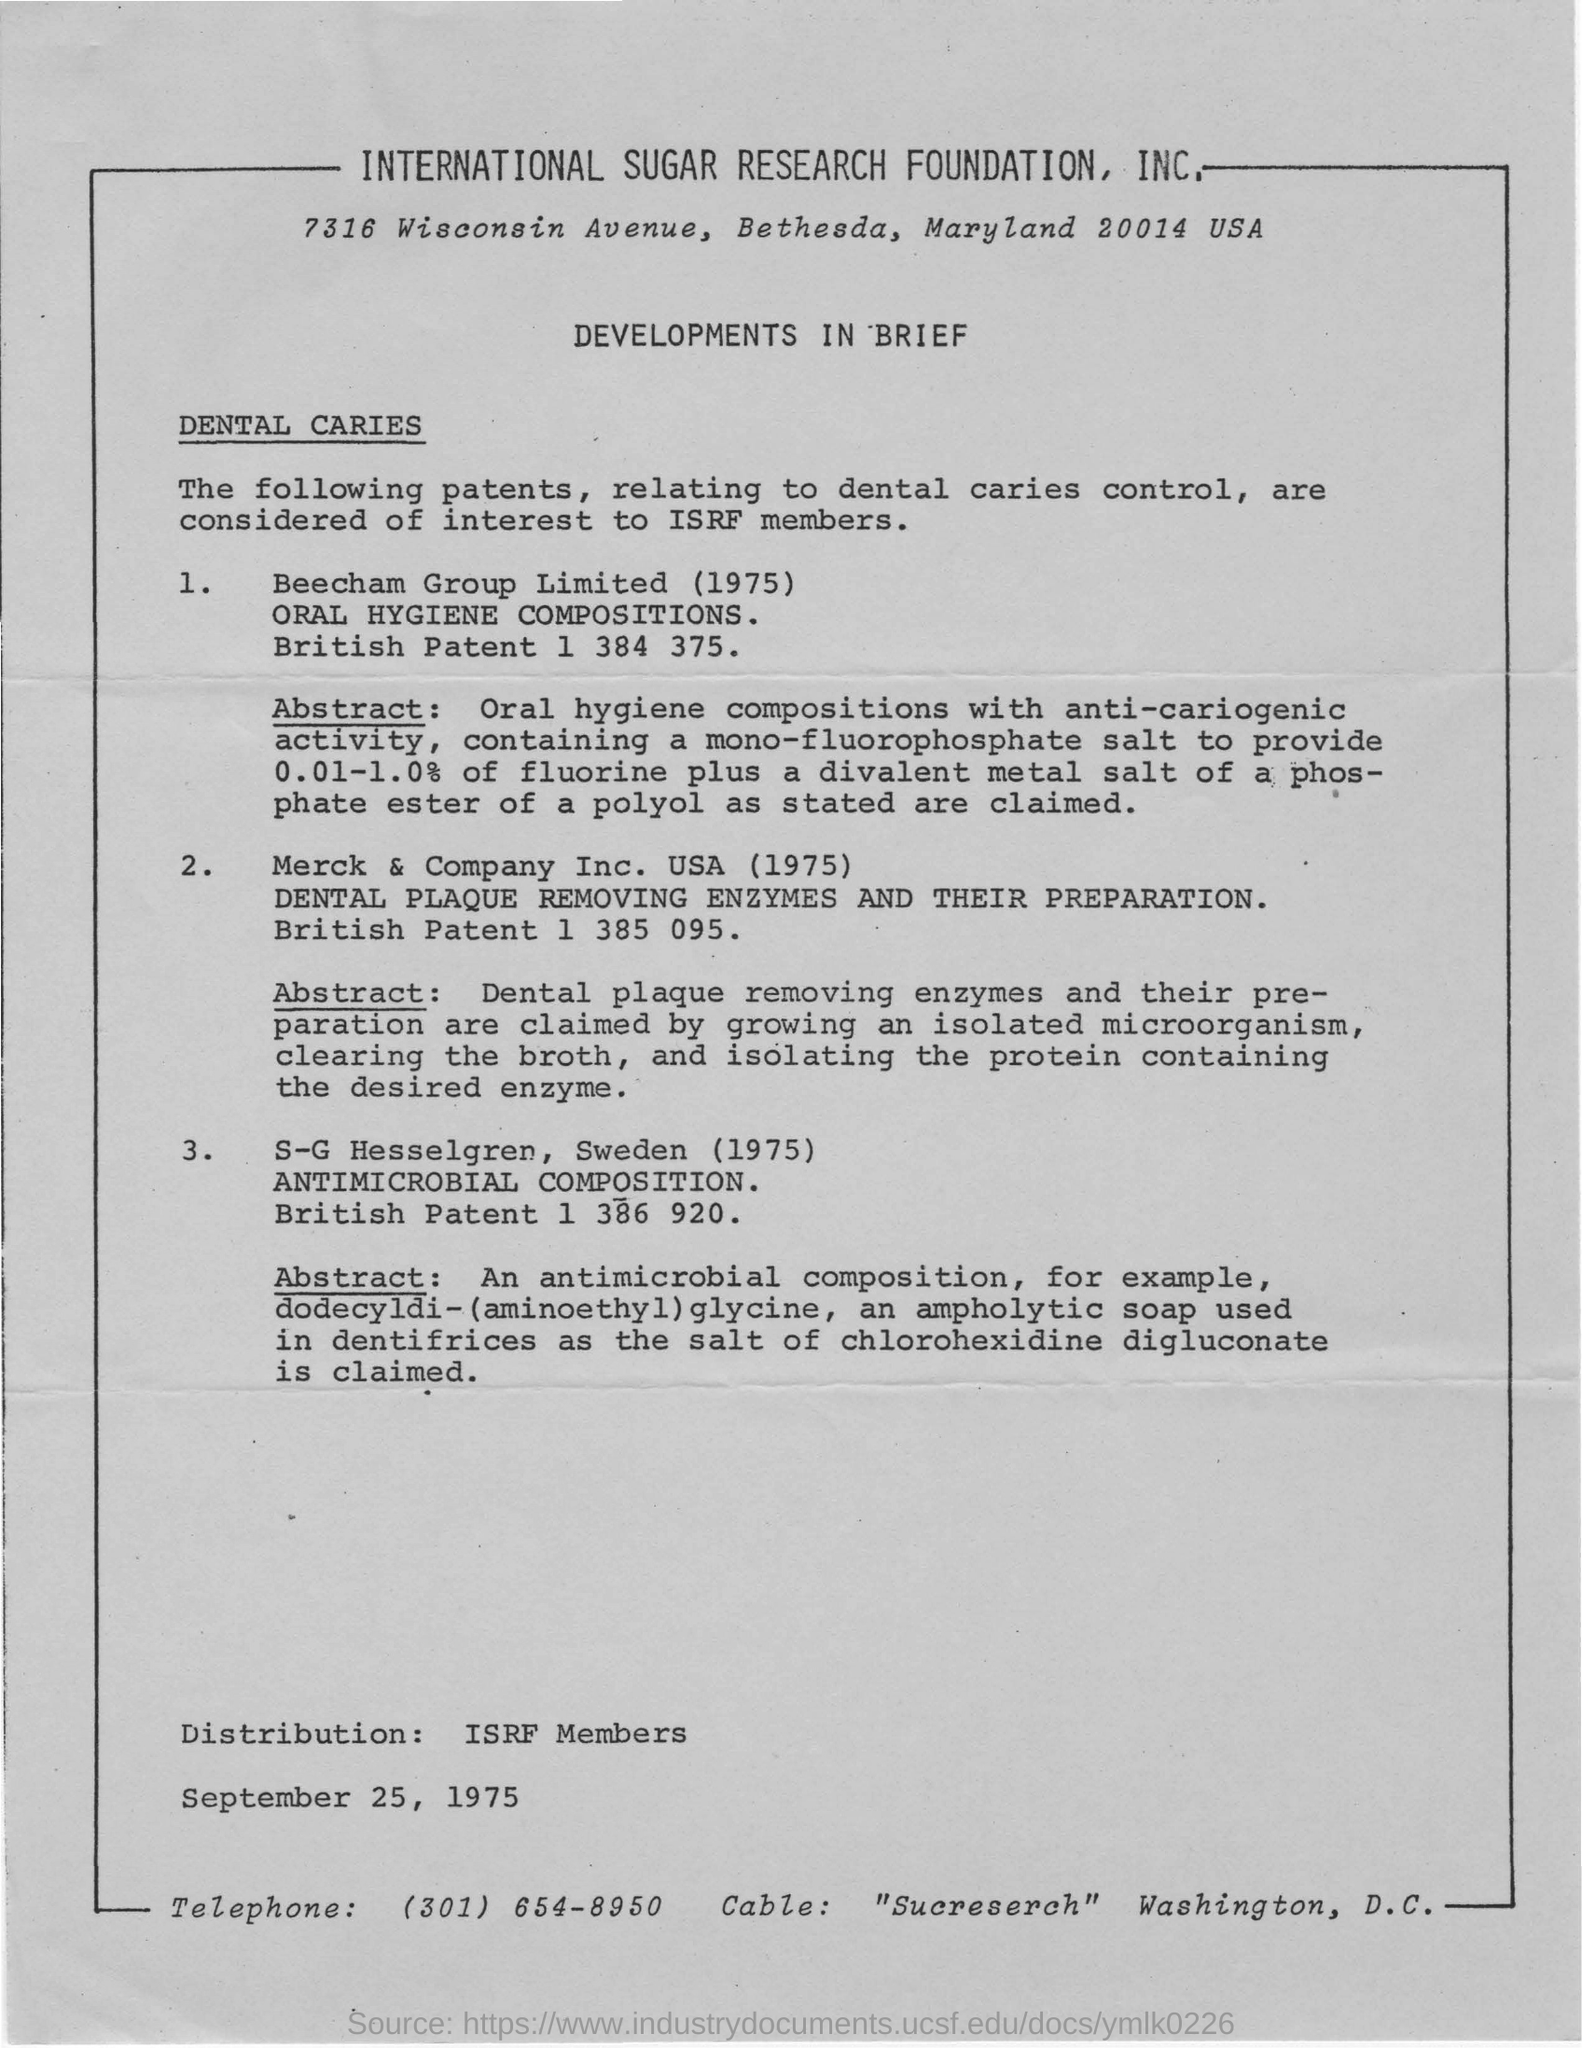Give some essential details in this illustration. The abbreviation of International Sugar Research Foundation is ISRF. Merck & Company, Inc. began operations in the United States in 1975. 